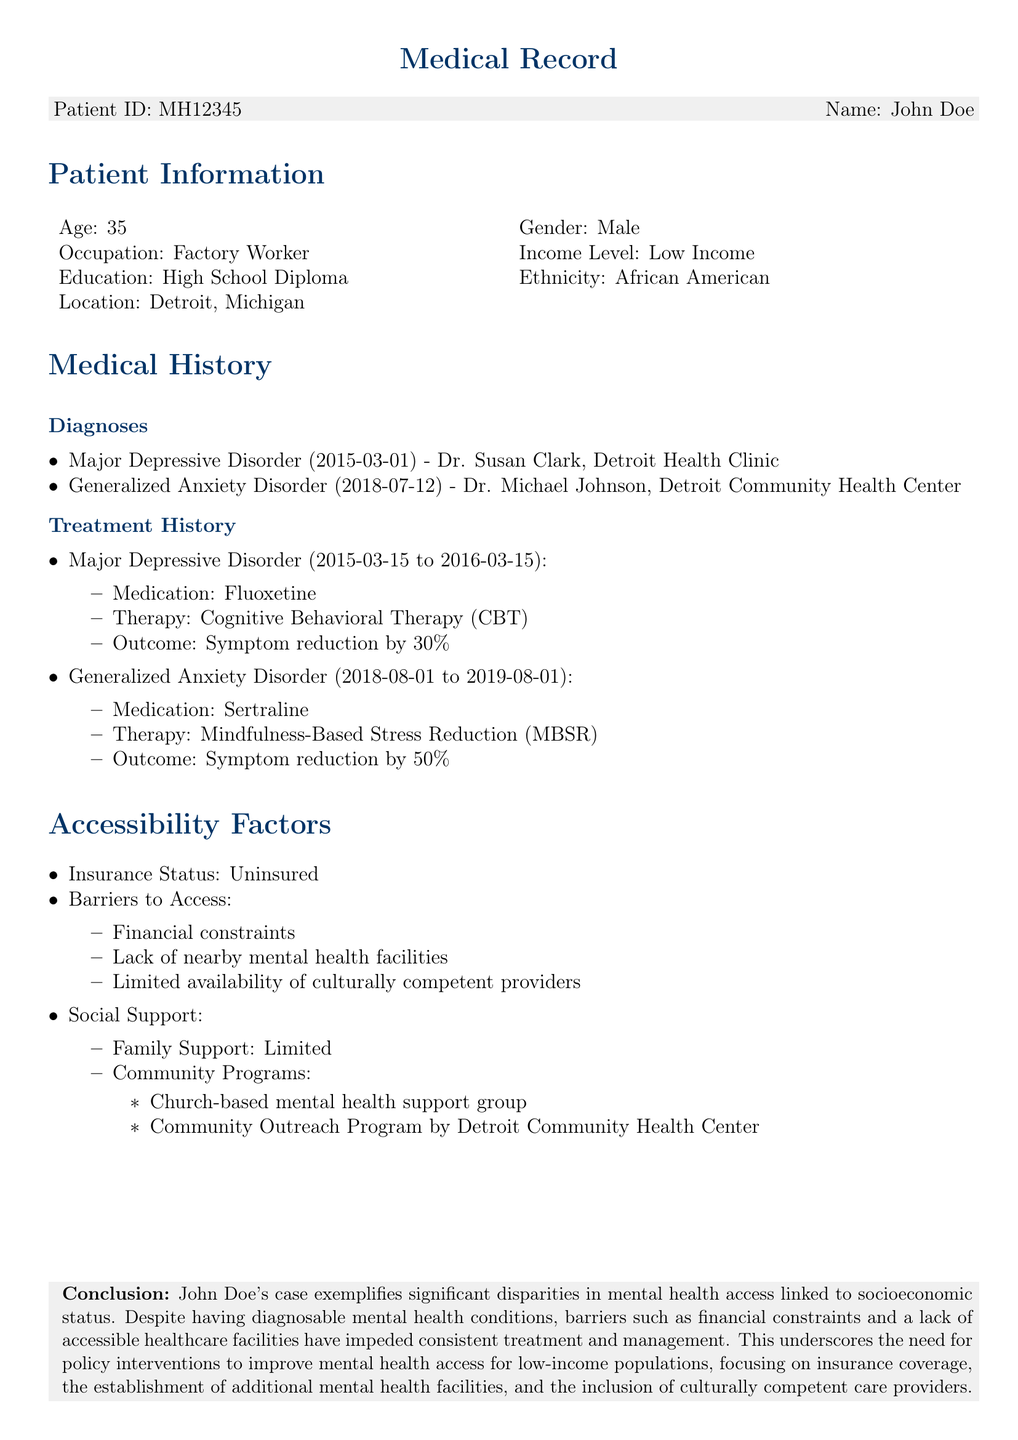What is the patient's ID? The patient's ID is specified at the beginning of the document, which is MH12345.
Answer: MH12345 What are the two diagnoses listed for the patient? The diagnoses section includes Major Depressive Disorder and Generalized Anxiety Disorder.
Answer: Major Depressive Disorder, Generalized Anxiety Disorder What was the medication prescribed for Major Depressive Disorder? The treatment history states that Fluoxetine was prescribed for Major Depressive Disorder.
Answer: Fluoxetine What is the income level of the patient? The document indicates that the patient's income level is Low Income.
Answer: Low Income How long did the patient receive treatment for Generalized Anxiety Disorder? Treatment for Generalized Anxiety Disorder lasted from August 1, 2018, to August 1, 2019, which is one year.
Answer: one year What barriers to access does the patient face? The document lists several barriers: financial constraints, lack of nearby mental health facilities, and limited availability of culturally competent providers.
Answer: financial constraints, lack of nearby mental health facilities, limited availability of culturally competent providers What type of community support program is mentioned? The document references a church-based mental health support group as a community program.
Answer: church-based mental health support group What is the conclusion regarding the patient's case? The conclusion emphasizes significant disparities in mental health access linked to socioeconomic status and the need for policy interventions.
Answer: significant disparities in mental health access linked to socioeconomic status What were the outcomes of the patient's therapy for Generalized Anxiety Disorder? The outcome of the therapy was a symptom reduction by 50%.
Answer: symptom reduction by 50% 